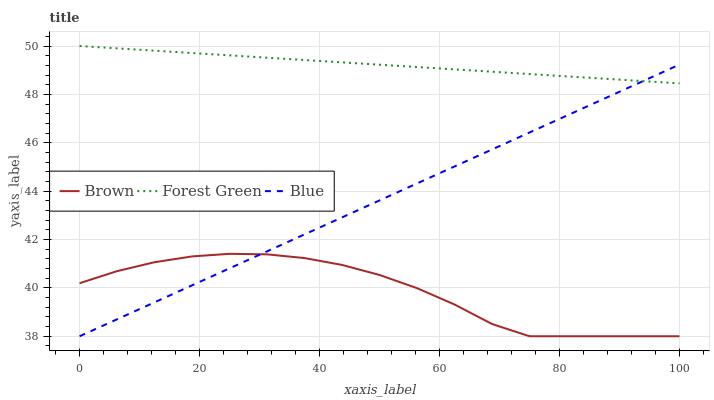Does Brown have the minimum area under the curve?
Answer yes or no. Yes. Does Forest Green have the maximum area under the curve?
Answer yes or no. Yes. Does Forest Green have the minimum area under the curve?
Answer yes or no. No. Does Brown have the maximum area under the curve?
Answer yes or no. No. Is Blue the smoothest?
Answer yes or no. Yes. Is Brown the roughest?
Answer yes or no. Yes. Is Forest Green the smoothest?
Answer yes or no. No. Is Forest Green the roughest?
Answer yes or no. No. Does Blue have the lowest value?
Answer yes or no. Yes. Does Forest Green have the lowest value?
Answer yes or no. No. Does Forest Green have the highest value?
Answer yes or no. Yes. Does Brown have the highest value?
Answer yes or no. No. Is Brown less than Forest Green?
Answer yes or no. Yes. Is Forest Green greater than Brown?
Answer yes or no. Yes. Does Brown intersect Blue?
Answer yes or no. Yes. Is Brown less than Blue?
Answer yes or no. No. Is Brown greater than Blue?
Answer yes or no. No. Does Brown intersect Forest Green?
Answer yes or no. No. 